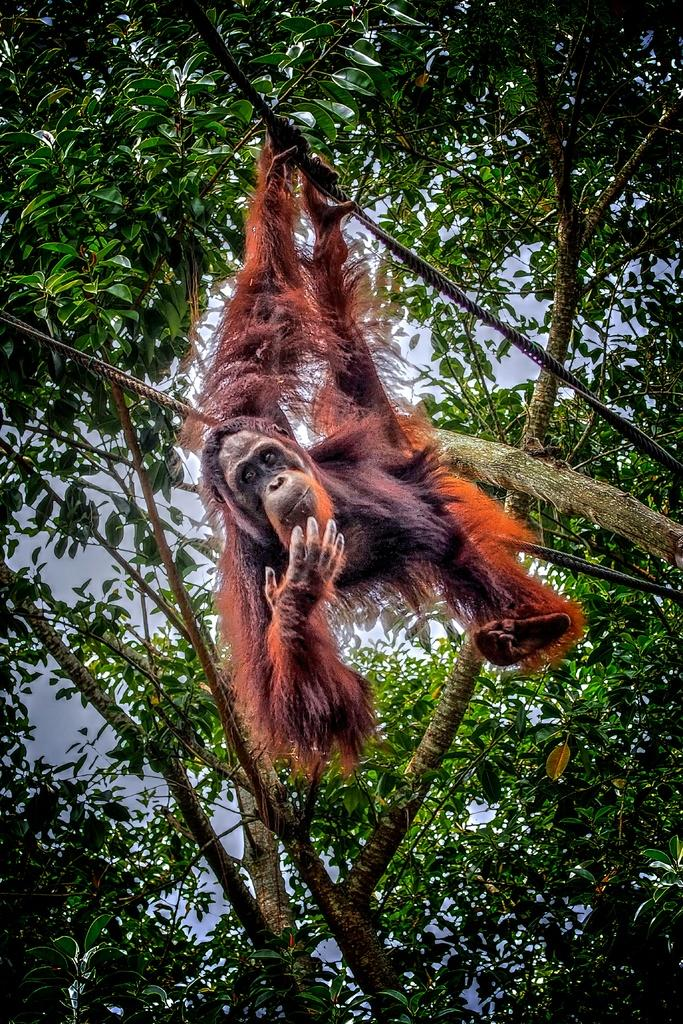What animal is the main subject of the image? There is an orangutan in the image. What is the orangutan doing in the image? The orangutan is hanging from a tree branch. What can be seen in the background of the image? There are trees and the sky visible in the background of the image. What type of steel structure can be seen in the image? There is no steel structure present in the image; it features an orangutan hanging from a tree branch. What is the orangutan using to communicate with the boats in the image? There are no boats or communication attempts present in the image. 